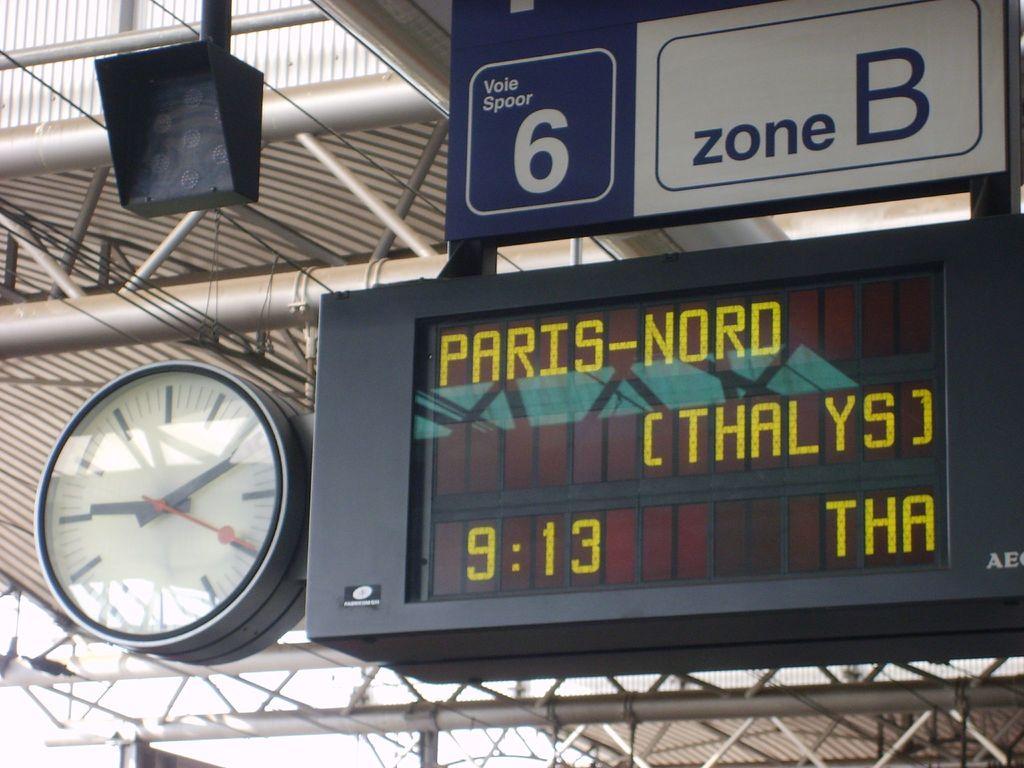Which place is this?
Offer a very short reply. Paris. What time is on the clock?
Your response must be concise. 9:13. 